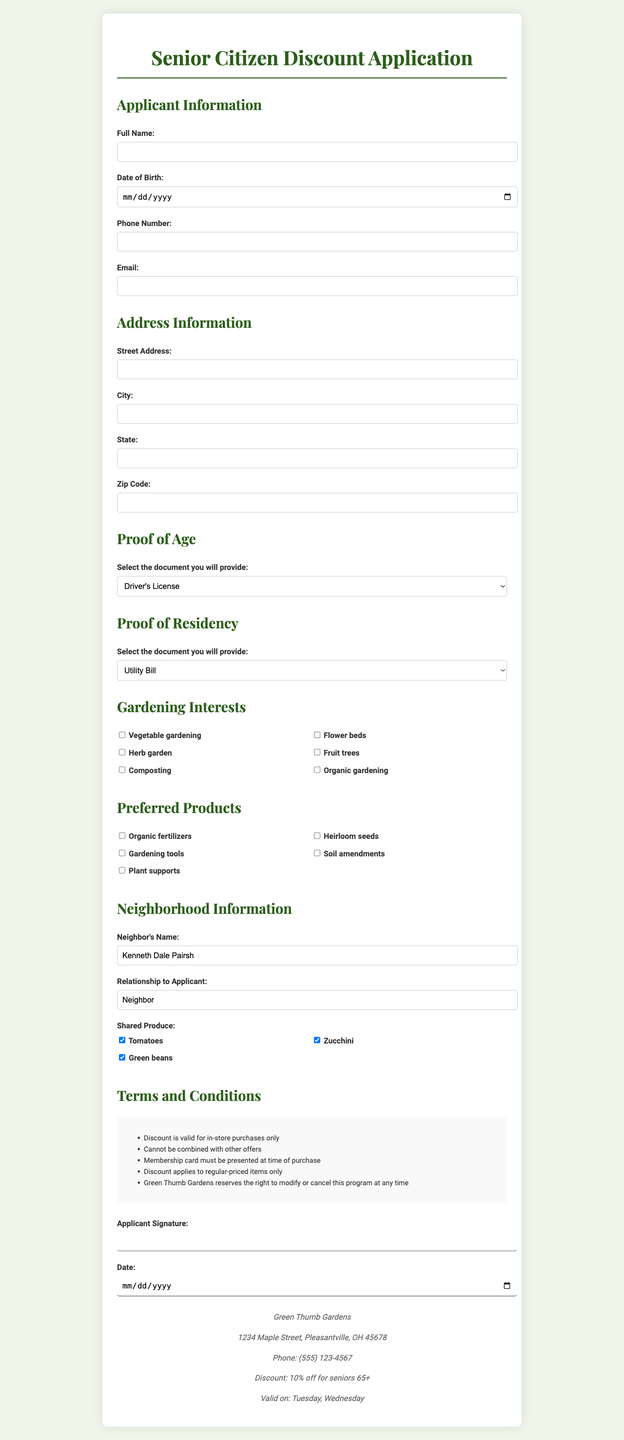what is the name of the store? The store's name is mentioned at the top of the document.
Answer: Green Thumb Gardens what is the address of the store? The address of the store is provided in the store information section.
Answer: 1234 Maple Street, Pleasantville, OH 45678 what is the discount percentage for seniors? The discount percentage offered to seniors is listed under discount details.
Answer: 10% what is the minimum age requirement for the discount? The document specifies the age requirement to be eligible for the discount.
Answer: 65 on which days is the discount valid? The valid days for the discount are mentioned in the discount details section.
Answer: Tuesday, Wednesday what document can be used as proof of age? The document lists various options for proof of age provided in a section.
Answer: Driver's License what documents are accepted as proof of residency? The proof of residency options are outlined in the corresponding section.
Answer: Utility Bill who is the neighbor mentioned in the document? The document includes the name of the neighbor in the neighborhood information section.
Answer: Kenneth Dale Pairsh what produce does the applicant share with their neighbor? The produce shared is listed in the neighborhood information section.
Answer: Tomatoes, Zucchini, Green beans 